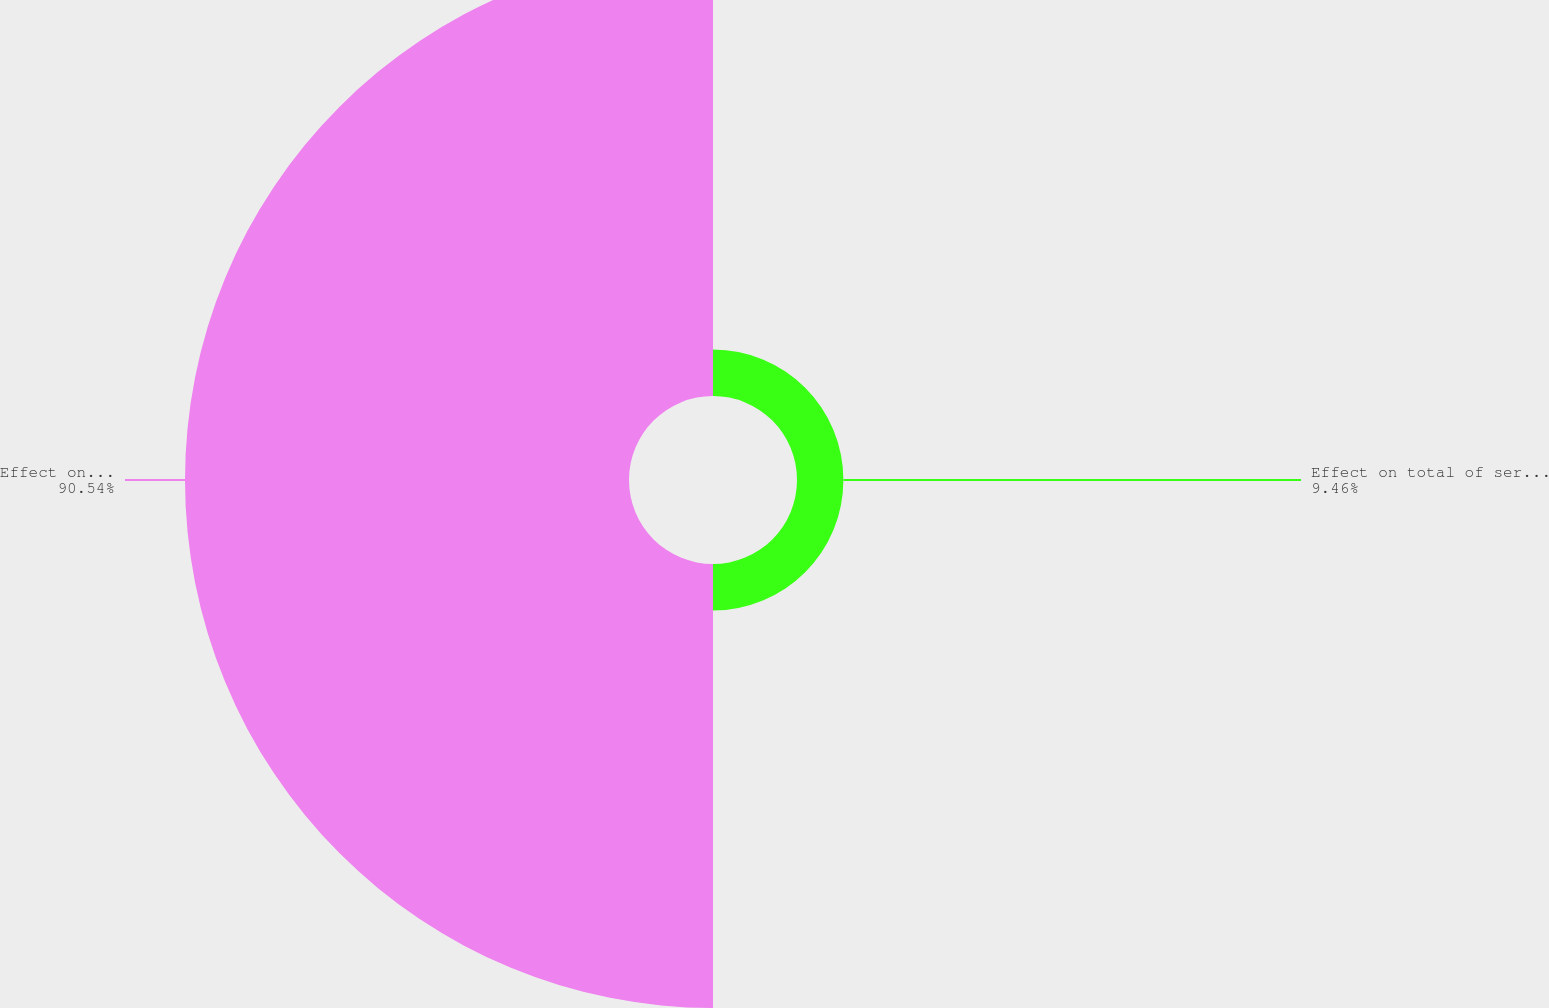<chart> <loc_0><loc_0><loc_500><loc_500><pie_chart><fcel>Effect on total of service and<fcel>Effect on postretirement<nl><fcel>9.46%<fcel>90.54%<nl></chart> 